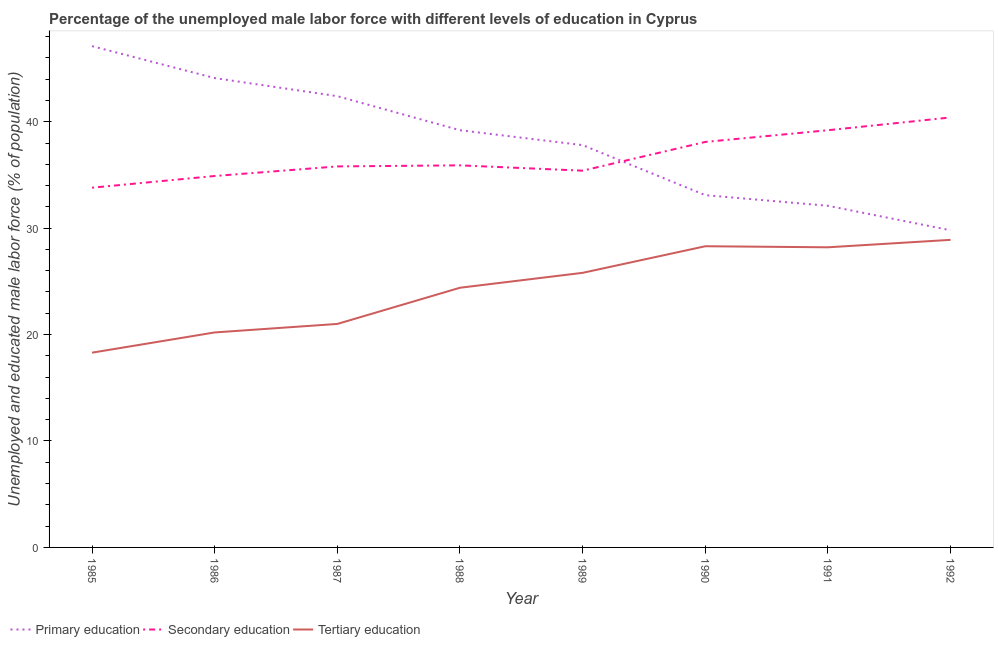How many different coloured lines are there?
Make the answer very short. 3. Does the line corresponding to percentage of male labor force who received secondary education intersect with the line corresponding to percentage of male labor force who received tertiary education?
Your answer should be very brief. No. What is the percentage of male labor force who received secondary education in 1992?
Your response must be concise. 40.4. Across all years, what is the maximum percentage of male labor force who received primary education?
Make the answer very short. 47.1. Across all years, what is the minimum percentage of male labor force who received primary education?
Offer a very short reply. 29.8. In which year was the percentage of male labor force who received secondary education maximum?
Ensure brevity in your answer.  1992. In which year was the percentage of male labor force who received secondary education minimum?
Your response must be concise. 1985. What is the total percentage of male labor force who received primary education in the graph?
Provide a succinct answer. 305.6. What is the difference between the percentage of male labor force who received primary education in 1989 and that in 1991?
Offer a terse response. 5.7. What is the difference between the percentage of male labor force who received secondary education in 1987 and the percentage of male labor force who received tertiary education in 1991?
Ensure brevity in your answer.  7.6. What is the average percentage of male labor force who received secondary education per year?
Provide a succinct answer. 36.69. In the year 1989, what is the difference between the percentage of male labor force who received secondary education and percentage of male labor force who received primary education?
Provide a short and direct response. -2.4. In how many years, is the percentage of male labor force who received tertiary education greater than 24 %?
Give a very brief answer. 5. What is the ratio of the percentage of male labor force who received secondary education in 1985 to that in 1991?
Offer a terse response. 0.86. Is the difference between the percentage of male labor force who received tertiary education in 1986 and 1987 greater than the difference between the percentage of male labor force who received primary education in 1986 and 1987?
Your response must be concise. No. What is the difference between the highest and the second highest percentage of male labor force who received secondary education?
Ensure brevity in your answer.  1.2. What is the difference between the highest and the lowest percentage of male labor force who received tertiary education?
Make the answer very short. 10.6. In how many years, is the percentage of male labor force who received tertiary education greater than the average percentage of male labor force who received tertiary education taken over all years?
Offer a terse response. 5. Is the sum of the percentage of male labor force who received secondary education in 1987 and 1991 greater than the maximum percentage of male labor force who received primary education across all years?
Provide a short and direct response. Yes. Is the percentage of male labor force who received secondary education strictly greater than the percentage of male labor force who received tertiary education over the years?
Offer a very short reply. Yes. How many lines are there?
Keep it short and to the point. 3. How are the legend labels stacked?
Your answer should be very brief. Horizontal. What is the title of the graph?
Offer a very short reply. Percentage of the unemployed male labor force with different levels of education in Cyprus. What is the label or title of the Y-axis?
Offer a very short reply. Unemployed and educated male labor force (% of population). What is the Unemployed and educated male labor force (% of population) in Primary education in 1985?
Provide a short and direct response. 47.1. What is the Unemployed and educated male labor force (% of population) of Secondary education in 1985?
Make the answer very short. 33.8. What is the Unemployed and educated male labor force (% of population) in Tertiary education in 1985?
Your answer should be very brief. 18.3. What is the Unemployed and educated male labor force (% of population) of Primary education in 1986?
Offer a very short reply. 44.1. What is the Unemployed and educated male labor force (% of population) in Secondary education in 1986?
Provide a short and direct response. 34.9. What is the Unemployed and educated male labor force (% of population) in Tertiary education in 1986?
Make the answer very short. 20.2. What is the Unemployed and educated male labor force (% of population) of Primary education in 1987?
Your response must be concise. 42.4. What is the Unemployed and educated male labor force (% of population) in Secondary education in 1987?
Your response must be concise. 35.8. What is the Unemployed and educated male labor force (% of population) in Tertiary education in 1987?
Give a very brief answer. 21. What is the Unemployed and educated male labor force (% of population) of Primary education in 1988?
Offer a very short reply. 39.2. What is the Unemployed and educated male labor force (% of population) in Secondary education in 1988?
Your response must be concise. 35.9. What is the Unemployed and educated male labor force (% of population) in Tertiary education in 1988?
Your answer should be compact. 24.4. What is the Unemployed and educated male labor force (% of population) of Primary education in 1989?
Keep it short and to the point. 37.8. What is the Unemployed and educated male labor force (% of population) of Secondary education in 1989?
Ensure brevity in your answer.  35.4. What is the Unemployed and educated male labor force (% of population) of Tertiary education in 1989?
Your answer should be compact. 25.8. What is the Unemployed and educated male labor force (% of population) of Primary education in 1990?
Give a very brief answer. 33.1. What is the Unemployed and educated male labor force (% of population) in Secondary education in 1990?
Provide a short and direct response. 38.1. What is the Unemployed and educated male labor force (% of population) of Tertiary education in 1990?
Provide a succinct answer. 28.3. What is the Unemployed and educated male labor force (% of population) of Primary education in 1991?
Provide a short and direct response. 32.1. What is the Unemployed and educated male labor force (% of population) of Secondary education in 1991?
Give a very brief answer. 39.2. What is the Unemployed and educated male labor force (% of population) in Tertiary education in 1991?
Provide a short and direct response. 28.2. What is the Unemployed and educated male labor force (% of population) of Primary education in 1992?
Offer a very short reply. 29.8. What is the Unemployed and educated male labor force (% of population) in Secondary education in 1992?
Provide a succinct answer. 40.4. What is the Unemployed and educated male labor force (% of population) of Tertiary education in 1992?
Your response must be concise. 28.9. Across all years, what is the maximum Unemployed and educated male labor force (% of population) of Primary education?
Keep it short and to the point. 47.1. Across all years, what is the maximum Unemployed and educated male labor force (% of population) of Secondary education?
Provide a short and direct response. 40.4. Across all years, what is the maximum Unemployed and educated male labor force (% of population) of Tertiary education?
Keep it short and to the point. 28.9. Across all years, what is the minimum Unemployed and educated male labor force (% of population) of Primary education?
Keep it short and to the point. 29.8. Across all years, what is the minimum Unemployed and educated male labor force (% of population) of Secondary education?
Give a very brief answer. 33.8. Across all years, what is the minimum Unemployed and educated male labor force (% of population) of Tertiary education?
Your answer should be compact. 18.3. What is the total Unemployed and educated male labor force (% of population) of Primary education in the graph?
Make the answer very short. 305.6. What is the total Unemployed and educated male labor force (% of population) in Secondary education in the graph?
Provide a succinct answer. 293.5. What is the total Unemployed and educated male labor force (% of population) in Tertiary education in the graph?
Your answer should be compact. 195.1. What is the difference between the Unemployed and educated male labor force (% of population) of Secondary education in 1985 and that in 1986?
Your answer should be very brief. -1.1. What is the difference between the Unemployed and educated male labor force (% of population) in Primary education in 1985 and that in 1987?
Ensure brevity in your answer.  4.7. What is the difference between the Unemployed and educated male labor force (% of population) of Tertiary education in 1985 and that in 1987?
Keep it short and to the point. -2.7. What is the difference between the Unemployed and educated male labor force (% of population) of Secondary education in 1985 and that in 1988?
Your answer should be very brief. -2.1. What is the difference between the Unemployed and educated male labor force (% of population) of Tertiary education in 1985 and that in 1988?
Give a very brief answer. -6.1. What is the difference between the Unemployed and educated male labor force (% of population) in Primary education in 1985 and that in 1989?
Your answer should be very brief. 9.3. What is the difference between the Unemployed and educated male labor force (% of population) of Secondary education in 1985 and that in 1989?
Ensure brevity in your answer.  -1.6. What is the difference between the Unemployed and educated male labor force (% of population) of Tertiary education in 1985 and that in 1989?
Provide a short and direct response. -7.5. What is the difference between the Unemployed and educated male labor force (% of population) of Secondary education in 1985 and that in 1990?
Offer a terse response. -4.3. What is the difference between the Unemployed and educated male labor force (% of population) in Primary education in 1985 and that in 1991?
Provide a succinct answer. 15. What is the difference between the Unemployed and educated male labor force (% of population) in Secondary education in 1985 and that in 1991?
Offer a very short reply. -5.4. What is the difference between the Unemployed and educated male labor force (% of population) in Secondary education in 1985 and that in 1992?
Your answer should be compact. -6.6. What is the difference between the Unemployed and educated male labor force (% of population) in Tertiary education in 1985 and that in 1992?
Provide a short and direct response. -10.6. What is the difference between the Unemployed and educated male labor force (% of population) of Primary education in 1986 and that in 1987?
Your answer should be very brief. 1.7. What is the difference between the Unemployed and educated male labor force (% of population) of Secondary education in 1986 and that in 1987?
Ensure brevity in your answer.  -0.9. What is the difference between the Unemployed and educated male labor force (% of population) in Tertiary education in 1986 and that in 1987?
Your response must be concise. -0.8. What is the difference between the Unemployed and educated male labor force (% of population) of Primary education in 1986 and that in 1988?
Provide a succinct answer. 4.9. What is the difference between the Unemployed and educated male labor force (% of population) of Secondary education in 1986 and that in 1988?
Keep it short and to the point. -1. What is the difference between the Unemployed and educated male labor force (% of population) of Tertiary education in 1986 and that in 1988?
Provide a short and direct response. -4.2. What is the difference between the Unemployed and educated male labor force (% of population) in Primary education in 1986 and that in 1989?
Offer a terse response. 6.3. What is the difference between the Unemployed and educated male labor force (% of population) in Secondary education in 1986 and that in 1989?
Your response must be concise. -0.5. What is the difference between the Unemployed and educated male labor force (% of population) in Tertiary education in 1986 and that in 1989?
Ensure brevity in your answer.  -5.6. What is the difference between the Unemployed and educated male labor force (% of population) of Primary education in 1986 and that in 1990?
Your answer should be very brief. 11. What is the difference between the Unemployed and educated male labor force (% of population) of Tertiary education in 1986 and that in 1990?
Your answer should be compact. -8.1. What is the difference between the Unemployed and educated male labor force (% of population) of Primary education in 1986 and that in 1991?
Make the answer very short. 12. What is the difference between the Unemployed and educated male labor force (% of population) in Tertiary education in 1986 and that in 1991?
Offer a terse response. -8. What is the difference between the Unemployed and educated male labor force (% of population) in Primary education in 1986 and that in 1992?
Ensure brevity in your answer.  14.3. What is the difference between the Unemployed and educated male labor force (% of population) of Secondary education in 1986 and that in 1992?
Your answer should be very brief. -5.5. What is the difference between the Unemployed and educated male labor force (% of population) in Tertiary education in 1986 and that in 1992?
Ensure brevity in your answer.  -8.7. What is the difference between the Unemployed and educated male labor force (% of population) of Primary education in 1987 and that in 1988?
Your response must be concise. 3.2. What is the difference between the Unemployed and educated male labor force (% of population) of Secondary education in 1987 and that in 1988?
Offer a very short reply. -0.1. What is the difference between the Unemployed and educated male labor force (% of population) of Primary education in 1987 and that in 1989?
Provide a succinct answer. 4.6. What is the difference between the Unemployed and educated male labor force (% of population) in Secondary education in 1987 and that in 1989?
Your response must be concise. 0.4. What is the difference between the Unemployed and educated male labor force (% of population) of Secondary education in 1987 and that in 1990?
Provide a succinct answer. -2.3. What is the difference between the Unemployed and educated male labor force (% of population) in Secondary education in 1987 and that in 1991?
Give a very brief answer. -3.4. What is the difference between the Unemployed and educated male labor force (% of population) in Tertiary education in 1987 and that in 1991?
Your answer should be very brief. -7.2. What is the difference between the Unemployed and educated male labor force (% of population) of Secondary education in 1987 and that in 1992?
Your answer should be compact. -4.6. What is the difference between the Unemployed and educated male labor force (% of population) of Primary education in 1988 and that in 1989?
Make the answer very short. 1.4. What is the difference between the Unemployed and educated male labor force (% of population) of Tertiary education in 1988 and that in 1989?
Provide a short and direct response. -1.4. What is the difference between the Unemployed and educated male labor force (% of population) of Secondary education in 1988 and that in 1990?
Your answer should be compact. -2.2. What is the difference between the Unemployed and educated male labor force (% of population) in Tertiary education in 1988 and that in 1991?
Your answer should be very brief. -3.8. What is the difference between the Unemployed and educated male labor force (% of population) of Secondary education in 1988 and that in 1992?
Provide a succinct answer. -4.5. What is the difference between the Unemployed and educated male labor force (% of population) in Tertiary education in 1989 and that in 1990?
Give a very brief answer. -2.5. What is the difference between the Unemployed and educated male labor force (% of population) of Primary education in 1989 and that in 1991?
Your answer should be compact. 5.7. What is the difference between the Unemployed and educated male labor force (% of population) in Secondary education in 1989 and that in 1991?
Offer a terse response. -3.8. What is the difference between the Unemployed and educated male labor force (% of population) of Secondary education in 1989 and that in 1992?
Offer a very short reply. -5. What is the difference between the Unemployed and educated male labor force (% of population) of Tertiary education in 1989 and that in 1992?
Keep it short and to the point. -3.1. What is the difference between the Unemployed and educated male labor force (% of population) in Primary education in 1990 and that in 1991?
Give a very brief answer. 1. What is the difference between the Unemployed and educated male labor force (% of population) of Tertiary education in 1990 and that in 1991?
Provide a succinct answer. 0.1. What is the difference between the Unemployed and educated male labor force (% of population) in Primary education in 1990 and that in 1992?
Provide a succinct answer. 3.3. What is the difference between the Unemployed and educated male labor force (% of population) of Secondary education in 1990 and that in 1992?
Give a very brief answer. -2.3. What is the difference between the Unemployed and educated male labor force (% of population) of Secondary education in 1991 and that in 1992?
Your answer should be compact. -1.2. What is the difference between the Unemployed and educated male labor force (% of population) in Tertiary education in 1991 and that in 1992?
Provide a short and direct response. -0.7. What is the difference between the Unemployed and educated male labor force (% of population) of Primary education in 1985 and the Unemployed and educated male labor force (% of population) of Tertiary education in 1986?
Keep it short and to the point. 26.9. What is the difference between the Unemployed and educated male labor force (% of population) of Primary education in 1985 and the Unemployed and educated male labor force (% of population) of Secondary education in 1987?
Keep it short and to the point. 11.3. What is the difference between the Unemployed and educated male labor force (% of population) of Primary education in 1985 and the Unemployed and educated male labor force (% of population) of Tertiary education in 1987?
Ensure brevity in your answer.  26.1. What is the difference between the Unemployed and educated male labor force (% of population) of Secondary education in 1985 and the Unemployed and educated male labor force (% of population) of Tertiary education in 1987?
Ensure brevity in your answer.  12.8. What is the difference between the Unemployed and educated male labor force (% of population) in Primary education in 1985 and the Unemployed and educated male labor force (% of population) in Tertiary education in 1988?
Ensure brevity in your answer.  22.7. What is the difference between the Unemployed and educated male labor force (% of population) of Secondary education in 1985 and the Unemployed and educated male labor force (% of population) of Tertiary education in 1988?
Provide a short and direct response. 9.4. What is the difference between the Unemployed and educated male labor force (% of population) of Primary education in 1985 and the Unemployed and educated male labor force (% of population) of Tertiary education in 1989?
Offer a very short reply. 21.3. What is the difference between the Unemployed and educated male labor force (% of population) in Secondary education in 1985 and the Unemployed and educated male labor force (% of population) in Tertiary education in 1989?
Offer a very short reply. 8. What is the difference between the Unemployed and educated male labor force (% of population) in Primary education in 1985 and the Unemployed and educated male labor force (% of population) in Secondary education in 1990?
Your response must be concise. 9. What is the difference between the Unemployed and educated male labor force (% of population) of Primary education in 1985 and the Unemployed and educated male labor force (% of population) of Tertiary education in 1990?
Offer a terse response. 18.8. What is the difference between the Unemployed and educated male labor force (% of population) of Secondary education in 1985 and the Unemployed and educated male labor force (% of population) of Tertiary education in 1990?
Your answer should be compact. 5.5. What is the difference between the Unemployed and educated male labor force (% of population) in Primary education in 1985 and the Unemployed and educated male labor force (% of population) in Tertiary education in 1991?
Give a very brief answer. 18.9. What is the difference between the Unemployed and educated male labor force (% of population) of Secondary education in 1985 and the Unemployed and educated male labor force (% of population) of Tertiary education in 1991?
Ensure brevity in your answer.  5.6. What is the difference between the Unemployed and educated male labor force (% of population) in Primary education in 1985 and the Unemployed and educated male labor force (% of population) in Secondary education in 1992?
Offer a very short reply. 6.7. What is the difference between the Unemployed and educated male labor force (% of population) of Primary education in 1986 and the Unemployed and educated male labor force (% of population) of Secondary education in 1987?
Your answer should be compact. 8.3. What is the difference between the Unemployed and educated male labor force (% of population) in Primary education in 1986 and the Unemployed and educated male labor force (% of population) in Tertiary education in 1987?
Provide a short and direct response. 23.1. What is the difference between the Unemployed and educated male labor force (% of population) of Secondary education in 1986 and the Unemployed and educated male labor force (% of population) of Tertiary education in 1987?
Your answer should be compact. 13.9. What is the difference between the Unemployed and educated male labor force (% of population) of Primary education in 1986 and the Unemployed and educated male labor force (% of population) of Tertiary education in 1989?
Make the answer very short. 18.3. What is the difference between the Unemployed and educated male labor force (% of population) of Secondary education in 1986 and the Unemployed and educated male labor force (% of population) of Tertiary education in 1989?
Make the answer very short. 9.1. What is the difference between the Unemployed and educated male labor force (% of population) in Primary education in 1986 and the Unemployed and educated male labor force (% of population) in Secondary education in 1990?
Ensure brevity in your answer.  6. What is the difference between the Unemployed and educated male labor force (% of population) of Primary education in 1986 and the Unemployed and educated male labor force (% of population) of Tertiary education in 1990?
Offer a very short reply. 15.8. What is the difference between the Unemployed and educated male labor force (% of population) in Secondary education in 1986 and the Unemployed and educated male labor force (% of population) in Tertiary education in 1990?
Provide a short and direct response. 6.6. What is the difference between the Unemployed and educated male labor force (% of population) of Primary education in 1986 and the Unemployed and educated male labor force (% of population) of Secondary education in 1991?
Provide a succinct answer. 4.9. What is the difference between the Unemployed and educated male labor force (% of population) in Primary education in 1987 and the Unemployed and educated male labor force (% of population) in Tertiary education in 1988?
Your answer should be compact. 18. What is the difference between the Unemployed and educated male labor force (% of population) in Secondary education in 1987 and the Unemployed and educated male labor force (% of population) in Tertiary education in 1988?
Make the answer very short. 11.4. What is the difference between the Unemployed and educated male labor force (% of population) of Primary education in 1987 and the Unemployed and educated male labor force (% of population) of Secondary education in 1989?
Your answer should be very brief. 7. What is the difference between the Unemployed and educated male labor force (% of population) in Secondary education in 1987 and the Unemployed and educated male labor force (% of population) in Tertiary education in 1989?
Offer a terse response. 10. What is the difference between the Unemployed and educated male labor force (% of population) of Primary education in 1987 and the Unemployed and educated male labor force (% of population) of Secondary education in 1990?
Make the answer very short. 4.3. What is the difference between the Unemployed and educated male labor force (% of population) in Secondary education in 1987 and the Unemployed and educated male labor force (% of population) in Tertiary education in 1990?
Keep it short and to the point. 7.5. What is the difference between the Unemployed and educated male labor force (% of population) of Primary education in 1987 and the Unemployed and educated male labor force (% of population) of Secondary education in 1992?
Offer a terse response. 2. What is the difference between the Unemployed and educated male labor force (% of population) of Secondary education in 1987 and the Unemployed and educated male labor force (% of population) of Tertiary education in 1992?
Make the answer very short. 6.9. What is the difference between the Unemployed and educated male labor force (% of population) in Primary education in 1988 and the Unemployed and educated male labor force (% of population) in Tertiary education in 1989?
Make the answer very short. 13.4. What is the difference between the Unemployed and educated male labor force (% of population) of Secondary education in 1988 and the Unemployed and educated male labor force (% of population) of Tertiary education in 1990?
Give a very brief answer. 7.6. What is the difference between the Unemployed and educated male labor force (% of population) of Primary education in 1988 and the Unemployed and educated male labor force (% of population) of Secondary education in 1991?
Your response must be concise. 0. What is the difference between the Unemployed and educated male labor force (% of population) in Primary education in 1988 and the Unemployed and educated male labor force (% of population) in Tertiary education in 1991?
Make the answer very short. 11. What is the difference between the Unemployed and educated male labor force (% of population) of Primary education in 1989 and the Unemployed and educated male labor force (% of population) of Tertiary education in 1990?
Provide a short and direct response. 9.5. What is the difference between the Unemployed and educated male labor force (% of population) of Primary education in 1989 and the Unemployed and educated male labor force (% of population) of Tertiary education in 1991?
Offer a terse response. 9.6. What is the average Unemployed and educated male labor force (% of population) of Primary education per year?
Offer a very short reply. 38.2. What is the average Unemployed and educated male labor force (% of population) in Secondary education per year?
Make the answer very short. 36.69. What is the average Unemployed and educated male labor force (% of population) in Tertiary education per year?
Give a very brief answer. 24.39. In the year 1985, what is the difference between the Unemployed and educated male labor force (% of population) of Primary education and Unemployed and educated male labor force (% of population) of Secondary education?
Your answer should be very brief. 13.3. In the year 1985, what is the difference between the Unemployed and educated male labor force (% of population) of Primary education and Unemployed and educated male labor force (% of population) of Tertiary education?
Keep it short and to the point. 28.8. In the year 1986, what is the difference between the Unemployed and educated male labor force (% of population) of Primary education and Unemployed and educated male labor force (% of population) of Secondary education?
Keep it short and to the point. 9.2. In the year 1986, what is the difference between the Unemployed and educated male labor force (% of population) of Primary education and Unemployed and educated male labor force (% of population) of Tertiary education?
Keep it short and to the point. 23.9. In the year 1987, what is the difference between the Unemployed and educated male labor force (% of population) of Primary education and Unemployed and educated male labor force (% of population) of Tertiary education?
Give a very brief answer. 21.4. In the year 1987, what is the difference between the Unemployed and educated male labor force (% of population) in Secondary education and Unemployed and educated male labor force (% of population) in Tertiary education?
Your answer should be very brief. 14.8. In the year 1988, what is the difference between the Unemployed and educated male labor force (% of population) of Primary education and Unemployed and educated male labor force (% of population) of Secondary education?
Give a very brief answer. 3.3. In the year 1988, what is the difference between the Unemployed and educated male labor force (% of population) in Primary education and Unemployed and educated male labor force (% of population) in Tertiary education?
Give a very brief answer. 14.8. In the year 1990, what is the difference between the Unemployed and educated male labor force (% of population) of Primary education and Unemployed and educated male labor force (% of population) of Tertiary education?
Give a very brief answer. 4.8. In the year 1991, what is the difference between the Unemployed and educated male labor force (% of population) of Primary education and Unemployed and educated male labor force (% of population) of Secondary education?
Provide a short and direct response. -7.1. In the year 1991, what is the difference between the Unemployed and educated male labor force (% of population) in Secondary education and Unemployed and educated male labor force (% of population) in Tertiary education?
Your response must be concise. 11. In the year 1992, what is the difference between the Unemployed and educated male labor force (% of population) of Primary education and Unemployed and educated male labor force (% of population) of Secondary education?
Offer a terse response. -10.6. In the year 1992, what is the difference between the Unemployed and educated male labor force (% of population) of Primary education and Unemployed and educated male labor force (% of population) of Tertiary education?
Ensure brevity in your answer.  0.9. What is the ratio of the Unemployed and educated male labor force (% of population) in Primary education in 1985 to that in 1986?
Make the answer very short. 1.07. What is the ratio of the Unemployed and educated male labor force (% of population) in Secondary education in 1985 to that in 1986?
Offer a terse response. 0.97. What is the ratio of the Unemployed and educated male labor force (% of population) in Tertiary education in 1985 to that in 1986?
Your answer should be compact. 0.91. What is the ratio of the Unemployed and educated male labor force (% of population) in Primary education in 1985 to that in 1987?
Keep it short and to the point. 1.11. What is the ratio of the Unemployed and educated male labor force (% of population) in Secondary education in 1985 to that in 1987?
Your response must be concise. 0.94. What is the ratio of the Unemployed and educated male labor force (% of population) in Tertiary education in 1985 to that in 1987?
Give a very brief answer. 0.87. What is the ratio of the Unemployed and educated male labor force (% of population) of Primary education in 1985 to that in 1988?
Keep it short and to the point. 1.2. What is the ratio of the Unemployed and educated male labor force (% of population) in Secondary education in 1985 to that in 1988?
Keep it short and to the point. 0.94. What is the ratio of the Unemployed and educated male labor force (% of population) in Primary education in 1985 to that in 1989?
Make the answer very short. 1.25. What is the ratio of the Unemployed and educated male labor force (% of population) in Secondary education in 1985 to that in 1989?
Ensure brevity in your answer.  0.95. What is the ratio of the Unemployed and educated male labor force (% of population) of Tertiary education in 1985 to that in 1989?
Give a very brief answer. 0.71. What is the ratio of the Unemployed and educated male labor force (% of population) in Primary education in 1985 to that in 1990?
Provide a short and direct response. 1.42. What is the ratio of the Unemployed and educated male labor force (% of population) of Secondary education in 1985 to that in 1990?
Your answer should be compact. 0.89. What is the ratio of the Unemployed and educated male labor force (% of population) of Tertiary education in 1985 to that in 1990?
Offer a very short reply. 0.65. What is the ratio of the Unemployed and educated male labor force (% of population) of Primary education in 1985 to that in 1991?
Your answer should be compact. 1.47. What is the ratio of the Unemployed and educated male labor force (% of population) in Secondary education in 1985 to that in 1991?
Your answer should be very brief. 0.86. What is the ratio of the Unemployed and educated male labor force (% of population) of Tertiary education in 1985 to that in 1991?
Offer a terse response. 0.65. What is the ratio of the Unemployed and educated male labor force (% of population) of Primary education in 1985 to that in 1992?
Your response must be concise. 1.58. What is the ratio of the Unemployed and educated male labor force (% of population) of Secondary education in 1985 to that in 1992?
Ensure brevity in your answer.  0.84. What is the ratio of the Unemployed and educated male labor force (% of population) in Tertiary education in 1985 to that in 1992?
Ensure brevity in your answer.  0.63. What is the ratio of the Unemployed and educated male labor force (% of population) of Primary education in 1986 to that in 1987?
Give a very brief answer. 1.04. What is the ratio of the Unemployed and educated male labor force (% of population) in Secondary education in 1986 to that in 1987?
Provide a short and direct response. 0.97. What is the ratio of the Unemployed and educated male labor force (% of population) in Tertiary education in 1986 to that in 1987?
Give a very brief answer. 0.96. What is the ratio of the Unemployed and educated male labor force (% of population) of Primary education in 1986 to that in 1988?
Provide a succinct answer. 1.12. What is the ratio of the Unemployed and educated male labor force (% of population) of Secondary education in 1986 to that in 1988?
Your response must be concise. 0.97. What is the ratio of the Unemployed and educated male labor force (% of population) in Tertiary education in 1986 to that in 1988?
Your response must be concise. 0.83. What is the ratio of the Unemployed and educated male labor force (% of population) of Secondary education in 1986 to that in 1989?
Keep it short and to the point. 0.99. What is the ratio of the Unemployed and educated male labor force (% of population) of Tertiary education in 1986 to that in 1989?
Your answer should be compact. 0.78. What is the ratio of the Unemployed and educated male labor force (% of population) of Primary education in 1986 to that in 1990?
Your answer should be compact. 1.33. What is the ratio of the Unemployed and educated male labor force (% of population) of Secondary education in 1986 to that in 1990?
Your answer should be very brief. 0.92. What is the ratio of the Unemployed and educated male labor force (% of population) in Tertiary education in 1986 to that in 1990?
Ensure brevity in your answer.  0.71. What is the ratio of the Unemployed and educated male labor force (% of population) of Primary education in 1986 to that in 1991?
Make the answer very short. 1.37. What is the ratio of the Unemployed and educated male labor force (% of population) of Secondary education in 1986 to that in 1991?
Provide a succinct answer. 0.89. What is the ratio of the Unemployed and educated male labor force (% of population) of Tertiary education in 1986 to that in 1991?
Give a very brief answer. 0.72. What is the ratio of the Unemployed and educated male labor force (% of population) in Primary education in 1986 to that in 1992?
Offer a terse response. 1.48. What is the ratio of the Unemployed and educated male labor force (% of population) in Secondary education in 1986 to that in 1992?
Keep it short and to the point. 0.86. What is the ratio of the Unemployed and educated male labor force (% of population) in Tertiary education in 1986 to that in 1992?
Your answer should be very brief. 0.7. What is the ratio of the Unemployed and educated male labor force (% of population) in Primary education in 1987 to that in 1988?
Make the answer very short. 1.08. What is the ratio of the Unemployed and educated male labor force (% of population) in Tertiary education in 1987 to that in 1988?
Provide a short and direct response. 0.86. What is the ratio of the Unemployed and educated male labor force (% of population) of Primary education in 1987 to that in 1989?
Your answer should be compact. 1.12. What is the ratio of the Unemployed and educated male labor force (% of population) in Secondary education in 1987 to that in 1989?
Make the answer very short. 1.01. What is the ratio of the Unemployed and educated male labor force (% of population) in Tertiary education in 1987 to that in 1989?
Your answer should be very brief. 0.81. What is the ratio of the Unemployed and educated male labor force (% of population) of Primary education in 1987 to that in 1990?
Offer a very short reply. 1.28. What is the ratio of the Unemployed and educated male labor force (% of population) of Secondary education in 1987 to that in 1990?
Offer a very short reply. 0.94. What is the ratio of the Unemployed and educated male labor force (% of population) in Tertiary education in 1987 to that in 1990?
Your answer should be compact. 0.74. What is the ratio of the Unemployed and educated male labor force (% of population) of Primary education in 1987 to that in 1991?
Give a very brief answer. 1.32. What is the ratio of the Unemployed and educated male labor force (% of population) in Secondary education in 1987 to that in 1991?
Your answer should be very brief. 0.91. What is the ratio of the Unemployed and educated male labor force (% of population) of Tertiary education in 1987 to that in 1991?
Ensure brevity in your answer.  0.74. What is the ratio of the Unemployed and educated male labor force (% of population) in Primary education in 1987 to that in 1992?
Your answer should be compact. 1.42. What is the ratio of the Unemployed and educated male labor force (% of population) of Secondary education in 1987 to that in 1992?
Ensure brevity in your answer.  0.89. What is the ratio of the Unemployed and educated male labor force (% of population) of Tertiary education in 1987 to that in 1992?
Give a very brief answer. 0.73. What is the ratio of the Unemployed and educated male labor force (% of population) in Secondary education in 1988 to that in 1989?
Offer a very short reply. 1.01. What is the ratio of the Unemployed and educated male labor force (% of population) of Tertiary education in 1988 to that in 1989?
Offer a terse response. 0.95. What is the ratio of the Unemployed and educated male labor force (% of population) of Primary education in 1988 to that in 1990?
Provide a short and direct response. 1.18. What is the ratio of the Unemployed and educated male labor force (% of population) of Secondary education in 1988 to that in 1990?
Provide a succinct answer. 0.94. What is the ratio of the Unemployed and educated male labor force (% of population) in Tertiary education in 1988 to that in 1990?
Your answer should be compact. 0.86. What is the ratio of the Unemployed and educated male labor force (% of population) in Primary education in 1988 to that in 1991?
Your answer should be compact. 1.22. What is the ratio of the Unemployed and educated male labor force (% of population) of Secondary education in 1988 to that in 1991?
Ensure brevity in your answer.  0.92. What is the ratio of the Unemployed and educated male labor force (% of population) in Tertiary education in 1988 to that in 1991?
Offer a very short reply. 0.87. What is the ratio of the Unemployed and educated male labor force (% of population) of Primary education in 1988 to that in 1992?
Offer a terse response. 1.32. What is the ratio of the Unemployed and educated male labor force (% of population) in Secondary education in 1988 to that in 1992?
Your response must be concise. 0.89. What is the ratio of the Unemployed and educated male labor force (% of population) of Tertiary education in 1988 to that in 1992?
Provide a succinct answer. 0.84. What is the ratio of the Unemployed and educated male labor force (% of population) of Primary education in 1989 to that in 1990?
Your answer should be very brief. 1.14. What is the ratio of the Unemployed and educated male labor force (% of population) of Secondary education in 1989 to that in 1990?
Your answer should be compact. 0.93. What is the ratio of the Unemployed and educated male labor force (% of population) in Tertiary education in 1989 to that in 1990?
Provide a short and direct response. 0.91. What is the ratio of the Unemployed and educated male labor force (% of population) in Primary education in 1989 to that in 1991?
Your answer should be compact. 1.18. What is the ratio of the Unemployed and educated male labor force (% of population) of Secondary education in 1989 to that in 1991?
Your answer should be very brief. 0.9. What is the ratio of the Unemployed and educated male labor force (% of population) of Tertiary education in 1989 to that in 1991?
Make the answer very short. 0.91. What is the ratio of the Unemployed and educated male labor force (% of population) of Primary education in 1989 to that in 1992?
Give a very brief answer. 1.27. What is the ratio of the Unemployed and educated male labor force (% of population) of Secondary education in 1989 to that in 1992?
Your answer should be compact. 0.88. What is the ratio of the Unemployed and educated male labor force (% of population) of Tertiary education in 1989 to that in 1992?
Ensure brevity in your answer.  0.89. What is the ratio of the Unemployed and educated male labor force (% of population) of Primary education in 1990 to that in 1991?
Offer a terse response. 1.03. What is the ratio of the Unemployed and educated male labor force (% of population) in Secondary education in 1990 to that in 1991?
Give a very brief answer. 0.97. What is the ratio of the Unemployed and educated male labor force (% of population) in Tertiary education in 1990 to that in 1991?
Ensure brevity in your answer.  1. What is the ratio of the Unemployed and educated male labor force (% of population) of Primary education in 1990 to that in 1992?
Provide a short and direct response. 1.11. What is the ratio of the Unemployed and educated male labor force (% of population) in Secondary education in 1990 to that in 1992?
Your response must be concise. 0.94. What is the ratio of the Unemployed and educated male labor force (% of population) of Tertiary education in 1990 to that in 1992?
Offer a very short reply. 0.98. What is the ratio of the Unemployed and educated male labor force (% of population) in Primary education in 1991 to that in 1992?
Offer a very short reply. 1.08. What is the ratio of the Unemployed and educated male labor force (% of population) of Secondary education in 1991 to that in 1992?
Provide a succinct answer. 0.97. What is the ratio of the Unemployed and educated male labor force (% of population) of Tertiary education in 1991 to that in 1992?
Provide a succinct answer. 0.98. What is the difference between the highest and the lowest Unemployed and educated male labor force (% of population) in Secondary education?
Ensure brevity in your answer.  6.6. What is the difference between the highest and the lowest Unemployed and educated male labor force (% of population) in Tertiary education?
Your answer should be compact. 10.6. 